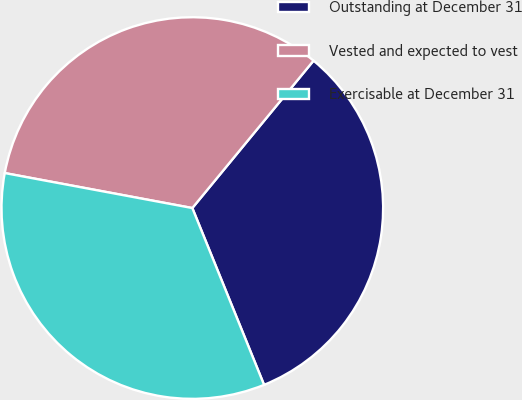<chart> <loc_0><loc_0><loc_500><loc_500><pie_chart><fcel>Outstanding at December 31<fcel>Vested and expected to vest<fcel>Exercisable at December 31<nl><fcel>32.91%<fcel>33.02%<fcel>34.07%<nl></chart> 